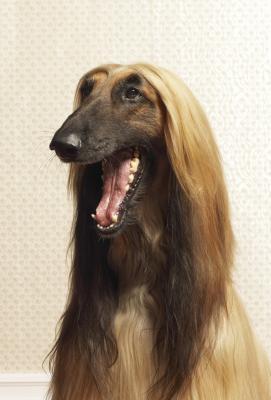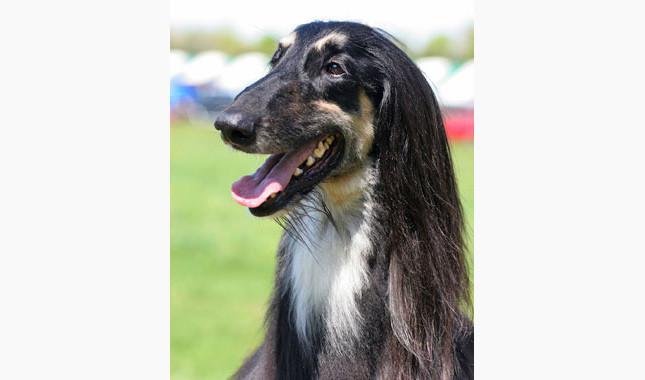The first image is the image on the left, the second image is the image on the right. Evaluate the accuracy of this statement regarding the images: "One image has a tan and white dog standing on grass.". Is it true? Answer yes or no. No. The first image is the image on the left, the second image is the image on the right. Analyze the images presented: Is the assertion "In one image there is a lone afghan hound standing outside" valid? Answer yes or no. No. 